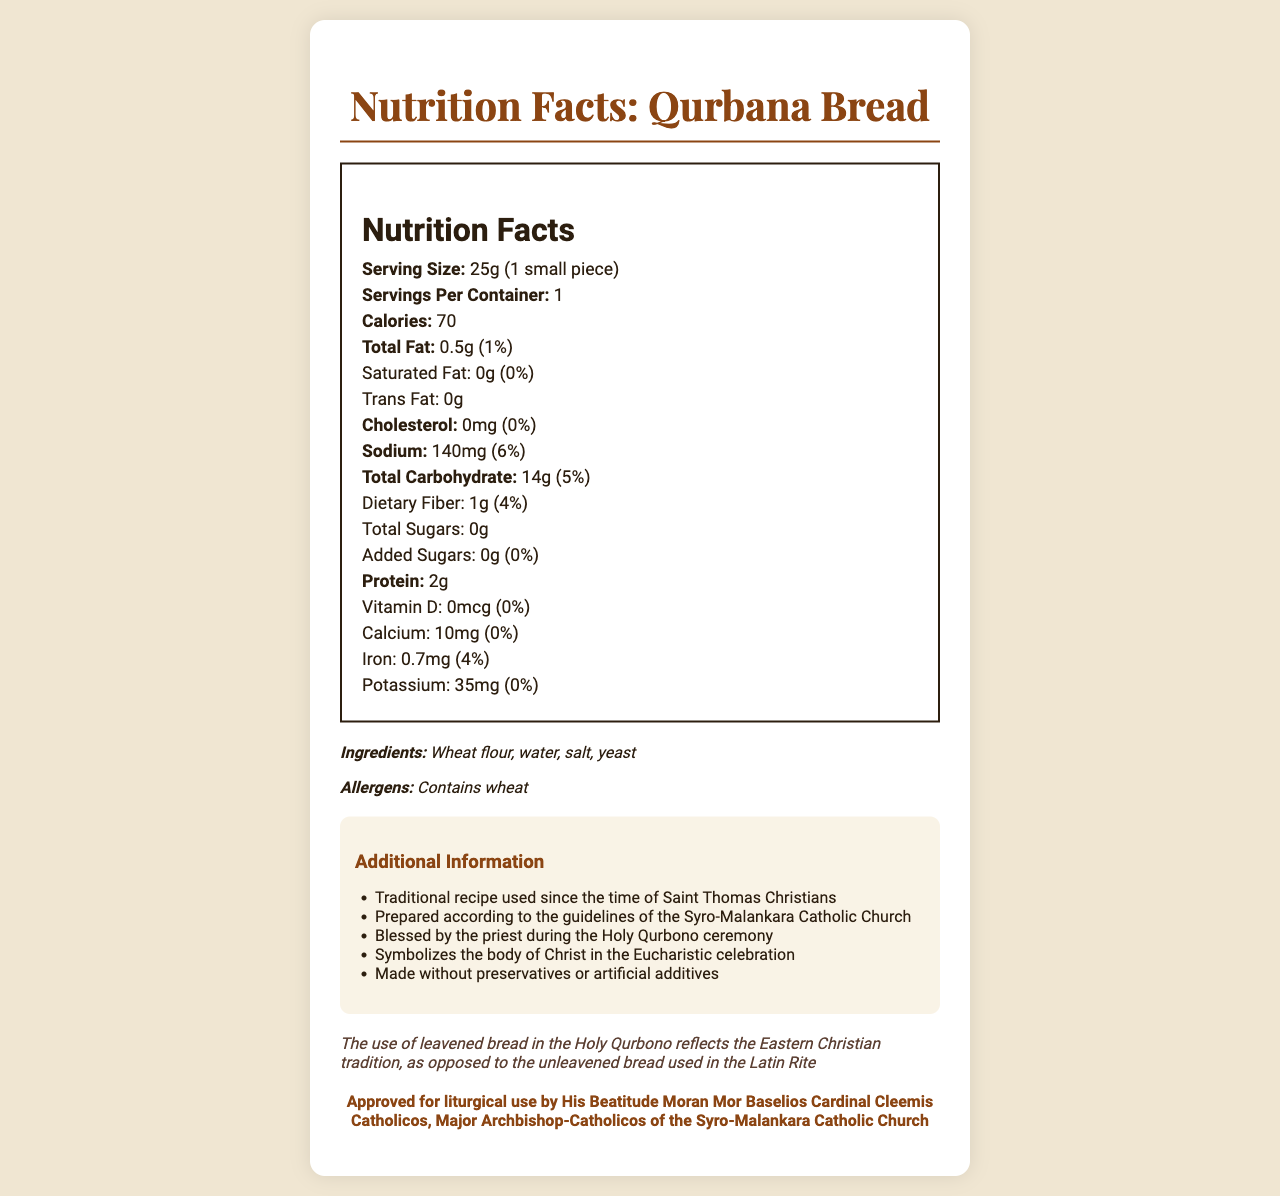what is the serving size of the bread? The serving size is listed as "25g (1 small piece)" in the document under the nutrition label.
Answer: 25g (1 small piece) how many calories are there per serving? The document states that there are 70 calories per serving.
Answer: 70 what is the total fat content per serving? It is mentioned in the nutrition facts that the total fat content per serving is 0.5g.
Answer: 0.5g how much sodium does the bread contain per serving? The nutrition label indicates that the bread contains 140mg of sodium per serving.
Answer: 140mg What is the main function of this bread in the Holy Qurbono ceremony? The document mentions that the bread symbolizes the body of Christ in the Eucharistic celebration.
Answer: Symbolizes the body of Christ which of the following nutrients is present in the highest amount in the bread? A. Protein B. Total Fat C. Total Carbohydrate D. Sodium The total carbohydrate amount is 14g, which is higher than protein at 2g, total fat at 0.5g, and sodium at 140mg.
Answer: C. Total Carbohydrate What percentage of your daily value of dietary fiber do you get from one serving? The nutrition label states that one serving provides 4% of the daily value for dietary fiber.
Answer: 4% Is there any added sugar in the Qurbana bread? The document indicates that there is 0g of added sugars.
Answer: No who approved this bread for liturgical use? A. Pope Francis B. His Beatitude Moran Mor Baselios Cardinal Cleemis Catholicos C. Archbishop Mar Aprem D. Bishop Jacob Angadiath The approval section states that the bread is approved for liturgical use by His Beatitude Moran Mor Baselios Cardinal Cleemis Catholicos.
Answer: B. His Beatitude Moran Mor Baselios Cardinal Cleemis Catholicos Is the bread made with artificial additives? The document mentions that the bread is made without preservatives or artificial additives.
Answer: No does the bread contain any allergens? The ingredients section states that the bread contains wheat.
Answer: Yes, it contains wheat summarize the main idea of the document. The document combines nutritional facts with historical and religious details, emphasizing the bread's liturgical use and symbolic meaning in the Eucharistic celebration without artificial additives.
Answer: The document provides nutritional information and historical context for the bread used in the Holy Qurbono of the Syro-Malankara Catholic Church, highlighting its ingredients, approval for liturgical use, and its symbolic significance. how is the bread used in the Syro-Malankara Catholic Church different from the one used in the Latin Rite? The historical note states that the use of leavened bread reflects the Eastern Christian tradition, unlike the unleavened bread used in the Latin Rite.
Answer: It is leavened while the Latin Rite uses unleavened bread how much vitamin D is present in the bread? The nutrition label shows that the vitamin D content is 0mcg.
Answer: 0mcg how long has the traditional recipe been used? The additional information section notes that the traditional recipe has been used since the time of Saint Thomas Christians.
Answer: Since the time of Saint Thomas Christians what is the significance of the bread being blessed by the priest during the Holy Qurbono ceremony? The additional information states that the bread is blessed by the priest during the Holy Qurbono, symbolizing the body of Christ in the Eucharistic celebration.
Answer: It is blessed by the priest to symbolize the body of Christ. which nutrient contributes most to the total calorie count? The bread contains 14g of carbohydrates, which would contribute more calories relative to protein (2g) and fat (0.5g).
Answer: Total Carbohydrate how much calcium does the bread have? The nutrition facts label lists calcium content as 10mg.
Answer: 10mg how is the bread prepared according to the guidelines of the church? The additional info section mentions that the bread is prepared following the church guidelines.
Answer: The bread is prepared according to the guidelines of the Syro-Malankara Catholic Church how many servings per container are there? The document states that there is 1 serving per container.
Answer: 1 Who originally composed the recipe of this bread? The document does not provide specific information about who originally composed the recipe.
Answer: Not enough information 